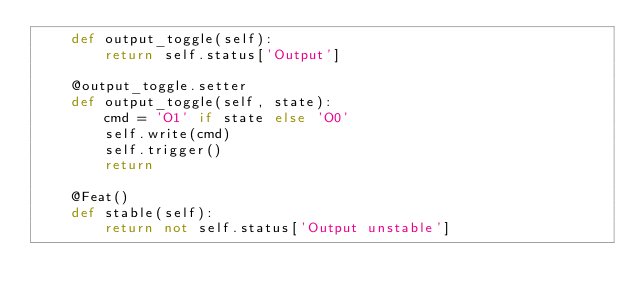<code> <loc_0><loc_0><loc_500><loc_500><_Python_>    def output_toggle(self):
        return self.status['Output']

    @output_toggle.setter
    def output_toggle(self, state):
        cmd = 'O1' if state else 'O0'
        self.write(cmd)
        self.trigger()
        return

    @Feat()
    def stable(self):
        return not self.status['Output unstable']
</code> 